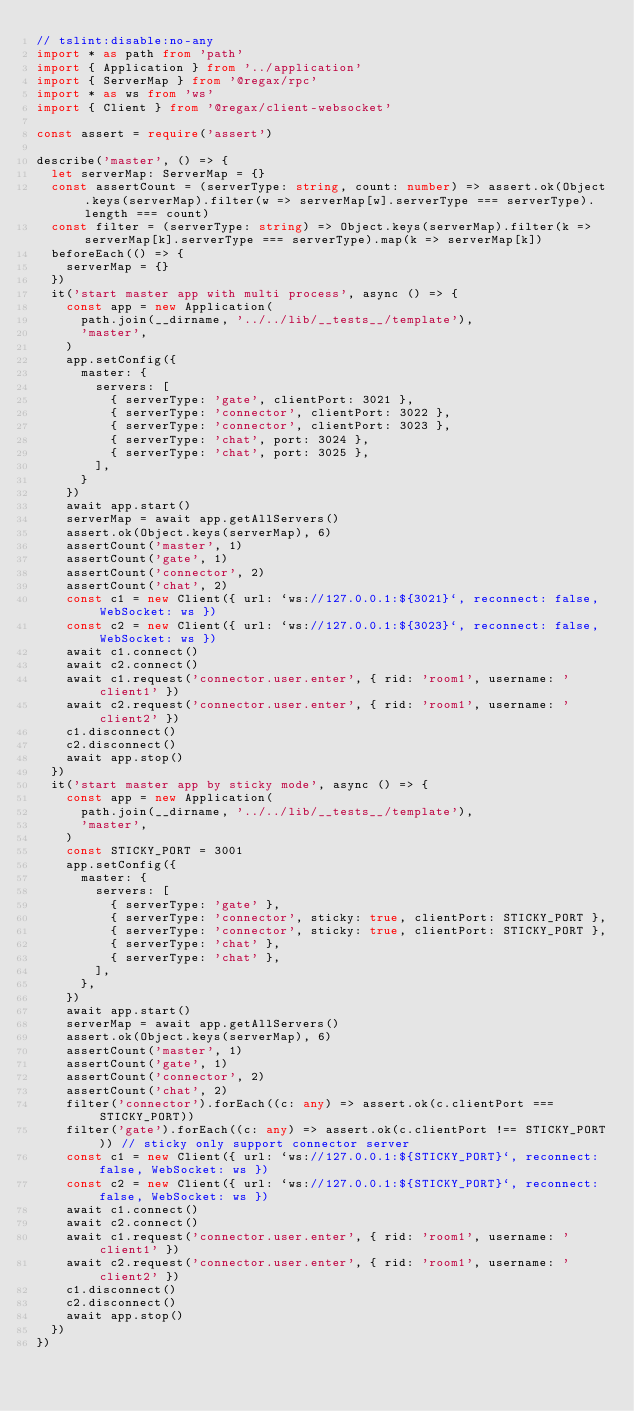Convert code to text. <code><loc_0><loc_0><loc_500><loc_500><_TypeScript_>// tslint:disable:no-any
import * as path from 'path'
import { Application } from '../application'
import { ServerMap } from '@regax/rpc'
import * as ws from 'ws'
import { Client } from '@regax/client-websocket'

const assert = require('assert')

describe('master', () => {
  let serverMap: ServerMap = {}
  const assertCount = (serverType: string, count: number) => assert.ok(Object.keys(serverMap).filter(w => serverMap[w].serverType === serverType).length === count)
  const filter = (serverType: string) => Object.keys(serverMap).filter(k => serverMap[k].serverType === serverType).map(k => serverMap[k])
  beforeEach(() => {
    serverMap = {}
  })
  it('start master app with multi process', async () => {
    const app = new Application(
      path.join(__dirname, '../../lib/__tests__/template'),
      'master',
    )
    app.setConfig({
      master: {
        servers: [
          { serverType: 'gate', clientPort: 3021 },
          { serverType: 'connector', clientPort: 3022 },
          { serverType: 'connector', clientPort: 3023 },
          { serverType: 'chat', port: 3024 },
          { serverType: 'chat', port: 3025 },
        ],
      }
    })
    await app.start()
    serverMap = await app.getAllServers()
    assert.ok(Object.keys(serverMap), 6)
    assertCount('master', 1)
    assertCount('gate', 1)
    assertCount('connector', 2)
    assertCount('chat', 2)
    const c1 = new Client({ url: `ws://127.0.0.1:${3021}`, reconnect: false, WebSocket: ws })
    const c2 = new Client({ url: `ws://127.0.0.1:${3023}`, reconnect: false, WebSocket: ws })
    await c1.connect()
    await c2.connect()
    await c1.request('connector.user.enter', { rid: 'room1', username: 'client1' })
    await c2.request('connector.user.enter', { rid: 'room1', username: 'client2' })
    c1.disconnect()
    c2.disconnect()
    await app.stop()
  })
  it('start master app by sticky mode', async () => {
    const app = new Application(
      path.join(__dirname, '../../lib/__tests__/template'),
      'master',
    )
    const STICKY_PORT = 3001
    app.setConfig({
      master: {
        servers: [
          { serverType: 'gate' },
          { serverType: 'connector', sticky: true, clientPort: STICKY_PORT },
          { serverType: 'connector', sticky: true, clientPort: STICKY_PORT },
          { serverType: 'chat' },
          { serverType: 'chat' },
        ],
      },
    })
    await app.start()
    serverMap = await app.getAllServers()
    assert.ok(Object.keys(serverMap), 6)
    assertCount('master', 1)
    assertCount('gate', 1)
    assertCount('connector', 2)
    assertCount('chat', 2)
    filter('connector').forEach((c: any) => assert.ok(c.clientPort === STICKY_PORT))
    filter('gate').forEach((c: any) => assert.ok(c.clientPort !== STICKY_PORT)) // sticky only support connector server
    const c1 = new Client({ url: `ws://127.0.0.1:${STICKY_PORT}`, reconnect: false, WebSocket: ws })
    const c2 = new Client({ url: `ws://127.0.0.1:${STICKY_PORT}`, reconnect: false, WebSocket: ws })
    await c1.connect()
    await c2.connect()
    await c1.request('connector.user.enter', { rid: 'room1', username: 'client1' })
    await c2.request('connector.user.enter', { rid: 'room1', username: 'client2' })
    c1.disconnect()
    c2.disconnect()
    await app.stop()
  })
})
</code> 